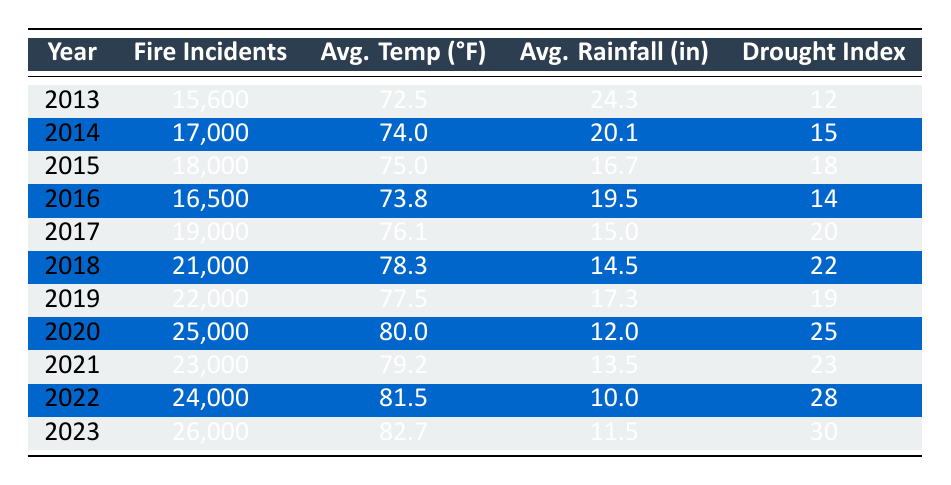What year had the highest number of fire incidents? The table lists fire incidents by year. To find the year with the highest number of incidents, we compare the values in the "Fire Incidents" column. The year 2023 has the highest value at 26,000 incidents.
Answer: 2023 What was the average temperature in 2016? Referring to the table, in the year 2016, the average temperature is specifically noted in the "Avg. Temp (°F)" column as 73.8 degrees Fahrenheit.
Answer: 73.8 How many fire incidents were reported in 2015 compared to 2022? In 2015, the fires reported were 18,000, while in 2022, it was 24,000. To find the difference, we subtract 18,000 from 24,000, giving us 6,000 more incidents in 2022.
Answer: 6,000 What is the average rainfall across the years presented? To calculate the average rainfall, we sum the rainfall from each year, which totals 24.3 + 20.1 + 16.7 + 19.5 + 15.0 + 14.5 + 17.3 + 12.0 + 13.5 + 10.0 + 11.5 =  14.52 inches, then divide that by 11 years to get an average of approximately 14.52 inches.
Answer: 14.52 Did the drought index increase every year from 2013 to 2023? A careful examination of the "Drought Index" column shows: 12, 15, 18, 14, 20, 22, 19, 25, 23, 28, and 30. The values do not consistently increase every year, as there were decreases in 2016 and 2019. Thus, it is false.
Answer: No What year experienced the lowest average rainfall? From the data, the rainfall for each year is compared. The lowest recorded was 10.0 inches in the year 2022, making it the year with the least rainfall.
Answer: 2022 What is the total number of fire incidents from 2013 to 2020? To find the total incidents, we add up all reported fires from 2013 to 2020: 15600 + 17000 + 18000 + 16500 + 19000 + 21000 + 22000 + 25000 = 115100. This indicates a total of 115,100 incidents during these years.
Answer: 115,100 Was the average temperature higher in 2023 compared to 2013? The average temperature in 2023 is 82.7 degrees Fahrenheit, while in 2013 it was 72.5 degrees Fahrenheit. To determine if it is higher, we compare the two values directly, and since 82.7 is greater than 72.5, the answer is true.
Answer: Yes 